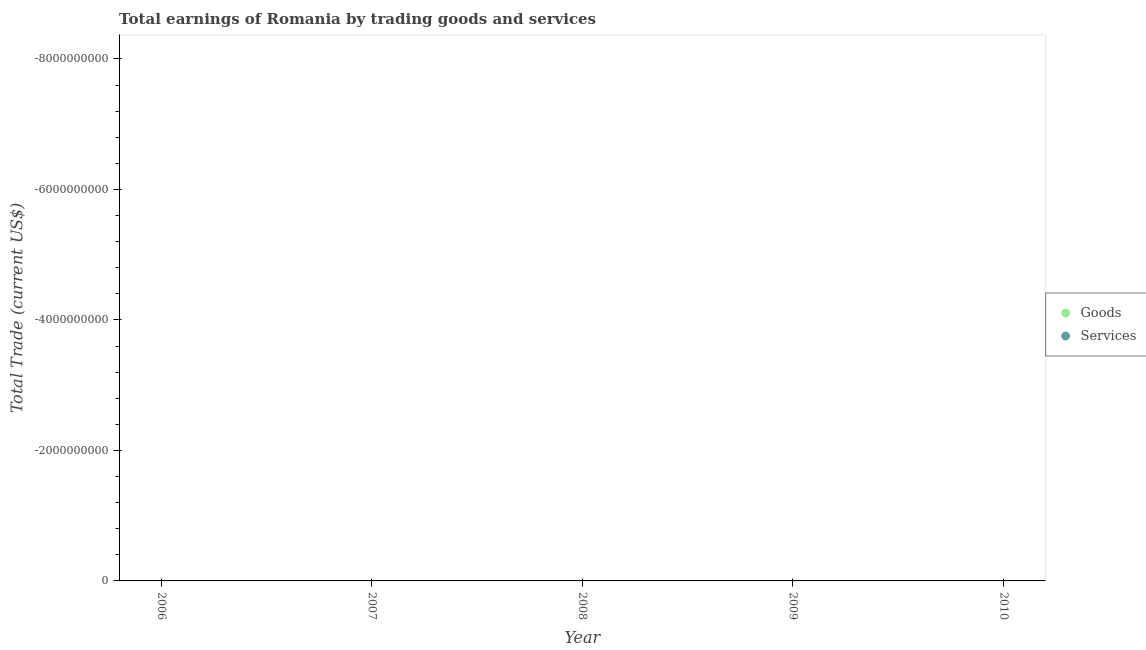How many different coloured dotlines are there?
Provide a short and direct response. 0. Is the number of dotlines equal to the number of legend labels?
Offer a terse response. No. Across all years, what is the minimum amount earned by trading services?
Offer a very short reply. 0. What is the total amount earned by trading services in the graph?
Provide a short and direct response. 0. What is the average amount earned by trading goods per year?
Offer a terse response. 0. In how many years, is the amount earned by trading services greater than -800000000 US$?
Ensure brevity in your answer.  0. In how many years, is the amount earned by trading services greater than the average amount earned by trading services taken over all years?
Ensure brevity in your answer.  0. Is the amount earned by trading goods strictly greater than the amount earned by trading services over the years?
Provide a short and direct response. No. How many dotlines are there?
Offer a terse response. 0. How many years are there in the graph?
Provide a short and direct response. 5. Does the graph contain any zero values?
Provide a short and direct response. Yes. Where does the legend appear in the graph?
Make the answer very short. Center right. How are the legend labels stacked?
Your answer should be compact. Vertical. What is the title of the graph?
Provide a succinct answer. Total earnings of Romania by trading goods and services. Does "Automatic Teller Machines" appear as one of the legend labels in the graph?
Offer a terse response. No. What is the label or title of the Y-axis?
Give a very brief answer. Total Trade (current US$). What is the Total Trade (current US$) in Services in 2006?
Provide a short and direct response. 0. What is the Total Trade (current US$) in Services in 2007?
Provide a succinct answer. 0. What is the Total Trade (current US$) of Services in 2008?
Offer a very short reply. 0. What is the Total Trade (current US$) of Services in 2009?
Offer a very short reply. 0. What is the Total Trade (current US$) of Goods in 2010?
Keep it short and to the point. 0. What is the total Total Trade (current US$) in Goods in the graph?
Your answer should be very brief. 0. What is the average Total Trade (current US$) of Services per year?
Your response must be concise. 0. 